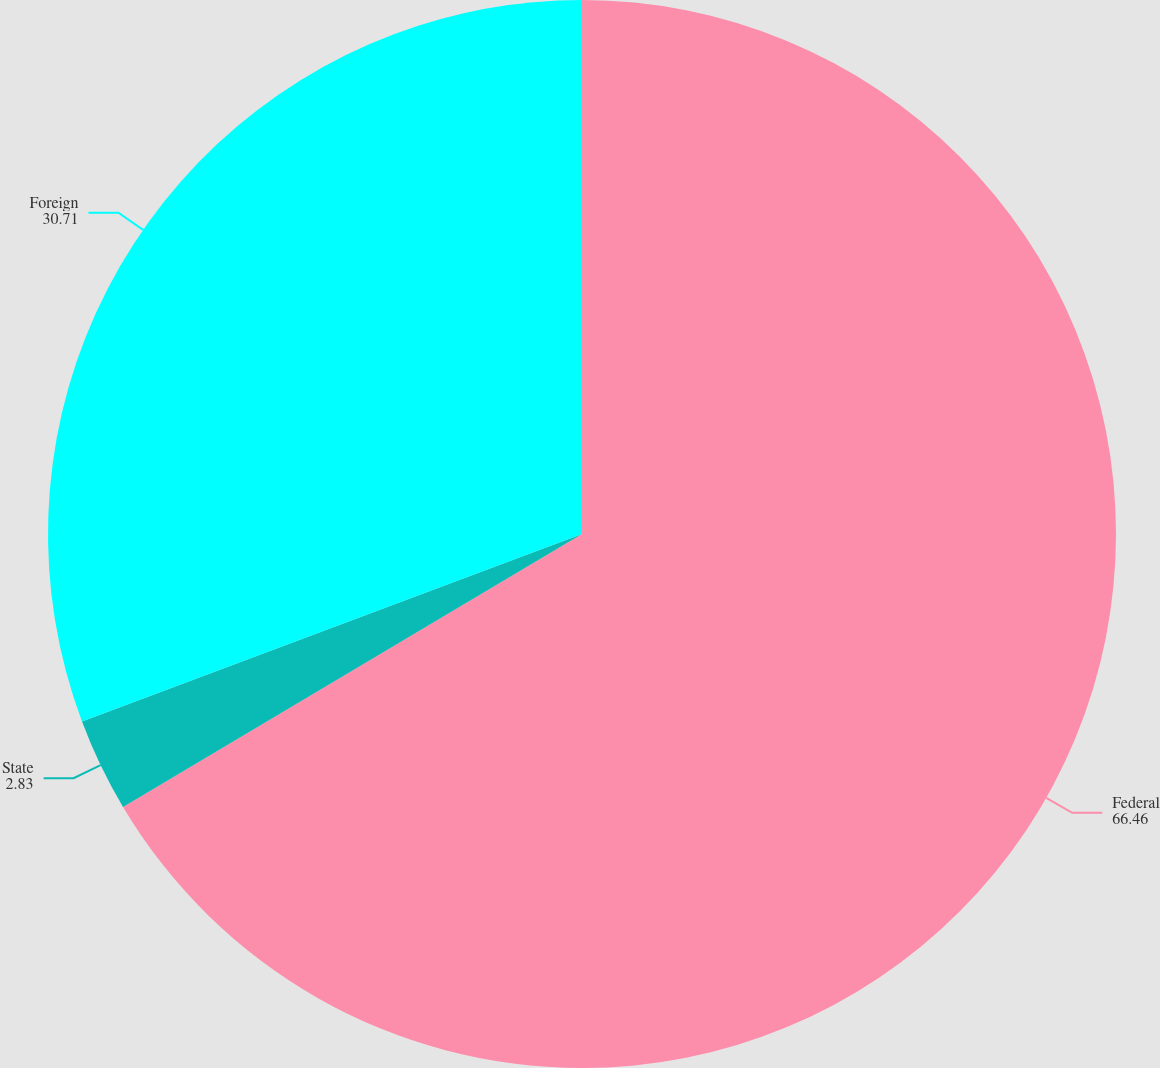Convert chart. <chart><loc_0><loc_0><loc_500><loc_500><pie_chart><fcel>Federal<fcel>State<fcel>Foreign<nl><fcel>66.46%<fcel>2.83%<fcel>30.71%<nl></chart> 